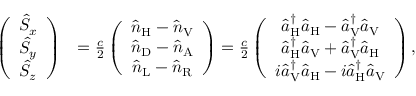<formula> <loc_0><loc_0><loc_500><loc_500>\begin{array} { r l } { \left ( \begin{array} { c } { \hat { S } _ { x } } \\ { \hat { S } _ { y } } \\ { \hat { S } _ { z } } \end{array} \right ) } & { = \frac { c } { 2 } \left ( \begin{array} { c } { \hat { n } _ { H } - \hat { n } _ { V } } \\ { \hat { n } _ { D } - \hat { n } _ { A } } \\ { \hat { n } _ { L } - \hat { n } _ { R } } \end{array} \right ) = \frac { c } { 2 } \left ( \begin{array} { c } { \hat { a } _ { H } ^ { \dagger } \hat { a } _ { H } - \hat { a } _ { V } ^ { \dagger } \hat { a } _ { V } } \\ { \hat { a } _ { H } ^ { \dagger } \hat { a } _ { V } + \hat { a } _ { V } ^ { \dagger } \hat { a } _ { H } } \\ { i \hat { a } _ { V } ^ { \dagger } \hat { a } _ { H } - i \hat { a } _ { H } ^ { \dagger } \hat { a } _ { V } } \end{array} \right ) , } \end{array}</formula> 